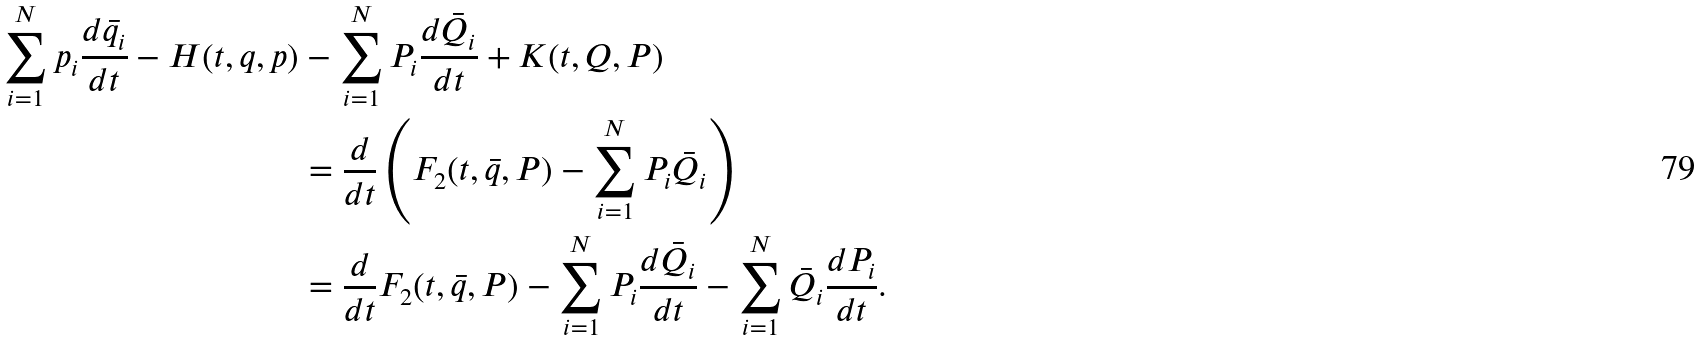Convert formula to latex. <formula><loc_0><loc_0><loc_500><loc_500>\sum _ { i = 1 } ^ { N } p _ { i } \frac { d \bar { q } _ { i } } { d t } - H ( t , q , p ) & - \sum _ { i = 1 } ^ { N } P _ { i } \frac { d \bar { Q } _ { i } } { d t } + K ( t , Q , P ) \\ & = \frac { d } { d t } \left ( F _ { 2 } ( t , \bar { q } , P ) - \sum _ { i = 1 } ^ { N } P _ { i } \bar { Q } _ { i } \right ) \\ & = \frac { d } { d t } F _ { 2 } ( t , \bar { q } , P ) - \sum _ { i = 1 } ^ { N } P _ { i } \frac { d \bar { Q } _ { i } } { d t } - \sum _ { i = 1 } ^ { N } \bar { Q } _ { i } \frac { d P _ { i } } { d t } .</formula> 